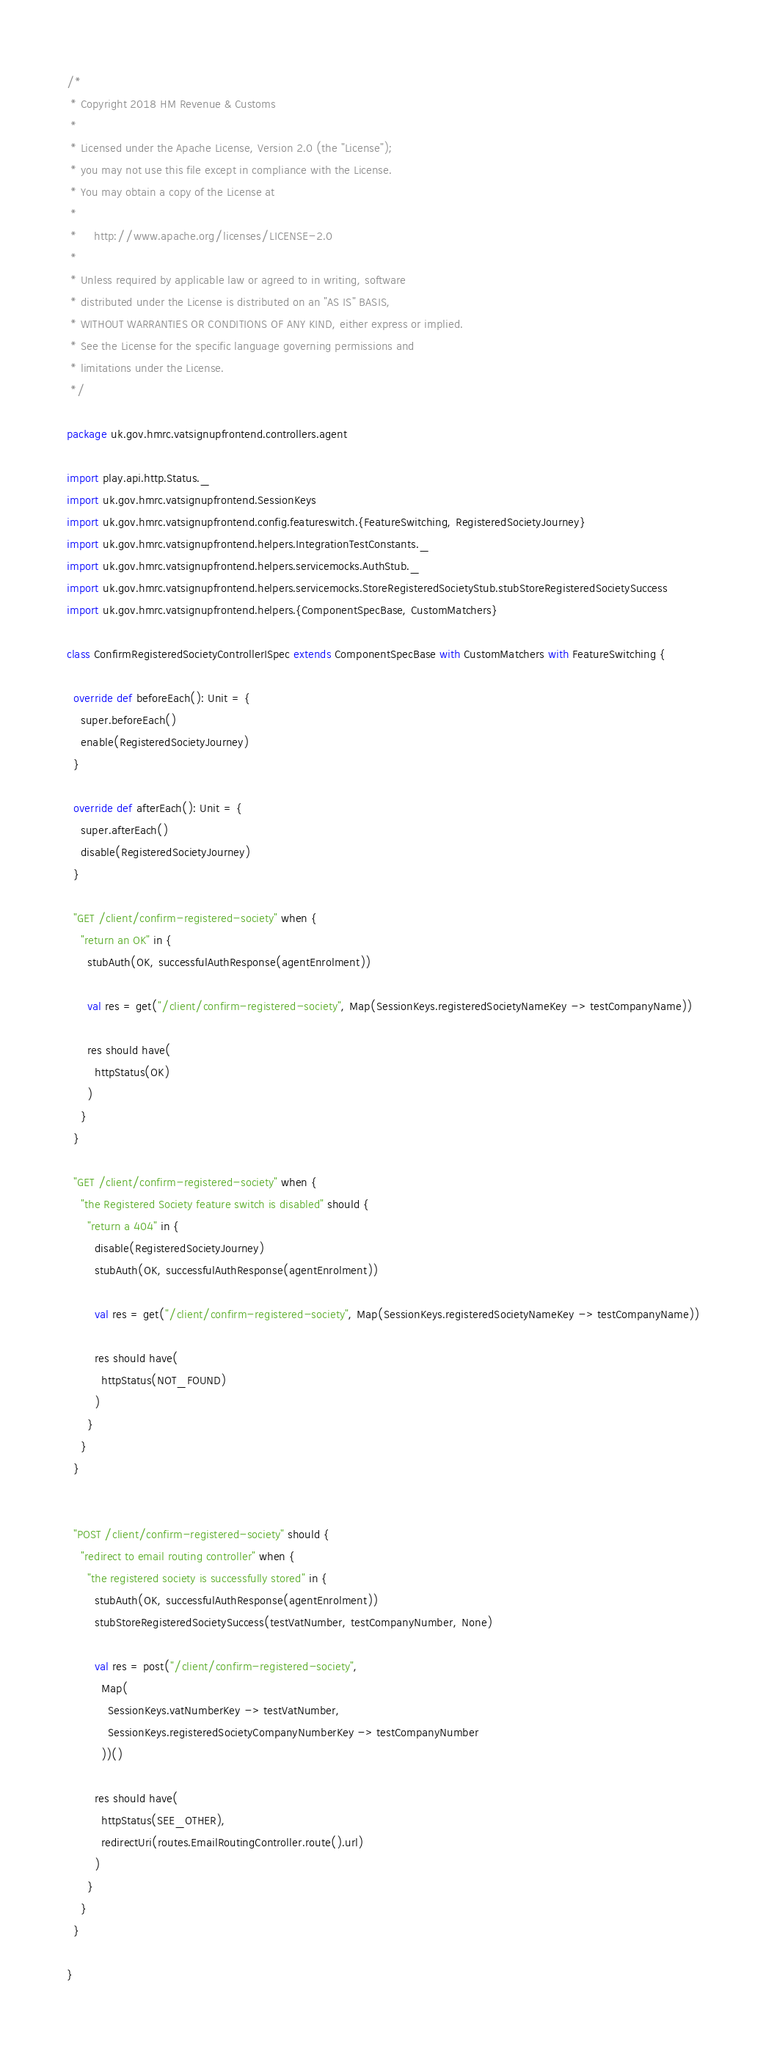Convert code to text. <code><loc_0><loc_0><loc_500><loc_500><_Scala_>/*
 * Copyright 2018 HM Revenue & Customs
 *
 * Licensed under the Apache License, Version 2.0 (the "License");
 * you may not use this file except in compliance with the License.
 * You may obtain a copy of the License at
 *
 *     http://www.apache.org/licenses/LICENSE-2.0
 *
 * Unless required by applicable law or agreed to in writing, software
 * distributed under the License is distributed on an "AS IS" BASIS,
 * WITHOUT WARRANTIES OR CONDITIONS OF ANY KIND, either express or implied.
 * See the License for the specific language governing permissions and
 * limitations under the License.
 */

package uk.gov.hmrc.vatsignupfrontend.controllers.agent

import play.api.http.Status._
import uk.gov.hmrc.vatsignupfrontend.SessionKeys
import uk.gov.hmrc.vatsignupfrontend.config.featureswitch.{FeatureSwitching, RegisteredSocietyJourney}
import uk.gov.hmrc.vatsignupfrontend.helpers.IntegrationTestConstants._
import uk.gov.hmrc.vatsignupfrontend.helpers.servicemocks.AuthStub._
import uk.gov.hmrc.vatsignupfrontend.helpers.servicemocks.StoreRegisteredSocietyStub.stubStoreRegisteredSocietySuccess
import uk.gov.hmrc.vatsignupfrontend.helpers.{ComponentSpecBase, CustomMatchers}

class ConfirmRegisteredSocietyControllerISpec extends ComponentSpecBase with CustomMatchers with FeatureSwitching {

  override def beforeEach(): Unit = {
    super.beforeEach()
    enable(RegisteredSocietyJourney)
  }

  override def afterEach(): Unit = {
    super.afterEach()
    disable(RegisteredSocietyJourney)
  }

  "GET /client/confirm-registered-society" when {
    "return an OK" in {
      stubAuth(OK, successfulAuthResponse(agentEnrolment))

      val res = get("/client/confirm-registered-society", Map(SessionKeys.registeredSocietyNameKey -> testCompanyName))

      res should have(
        httpStatus(OK)
      )
    }
  }

  "GET /client/confirm-registered-society" when {
    "the Registered Society feature switch is disabled" should {
      "return a 404" in {
        disable(RegisteredSocietyJourney)
        stubAuth(OK, successfulAuthResponse(agentEnrolment))

        val res = get("/client/confirm-registered-society", Map(SessionKeys.registeredSocietyNameKey -> testCompanyName))

        res should have(
          httpStatus(NOT_FOUND)
        )
      }
    }
  }


  "POST /client/confirm-registered-society" should {
    "redirect to email routing controller" when {
      "the registered society is successfully stored" in {
        stubAuth(OK, successfulAuthResponse(agentEnrolment))
        stubStoreRegisteredSocietySuccess(testVatNumber, testCompanyNumber, None)

        val res = post("/client/confirm-registered-society",
          Map(
            SessionKeys.vatNumberKey -> testVatNumber,
            SessionKeys.registeredSocietyCompanyNumberKey -> testCompanyNumber
          ))()

        res should have(
          httpStatus(SEE_OTHER),
          redirectUri(routes.EmailRoutingController.route().url)
        )
      }
    }
  }

}
</code> 